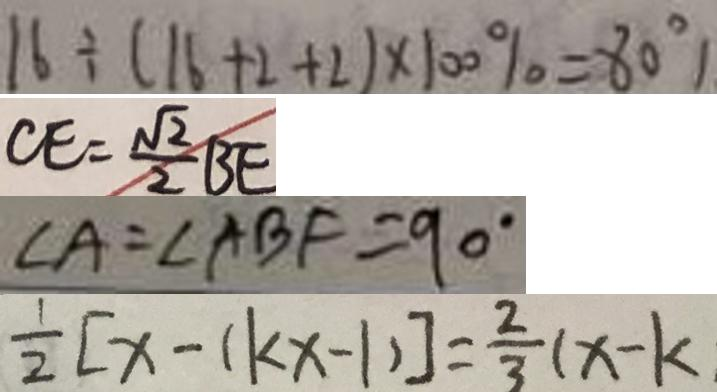Convert formula to latex. <formula><loc_0><loc_0><loc_500><loc_500>1 6 \div ( 1 6 + 2 + 2 ) \times 1 0 0 \% = 8 0 ^ { \circ } 
 C E = \frac { \sqrt { 2 } } { 2 } B E 
 \angle A = \angle A B F = 9 0 ^ { \circ } 
 \frac { 1 } { 2 } [ x - ( k x - 1 ) ] = \frac { 2 } { 3 } ( x - k )</formula> 